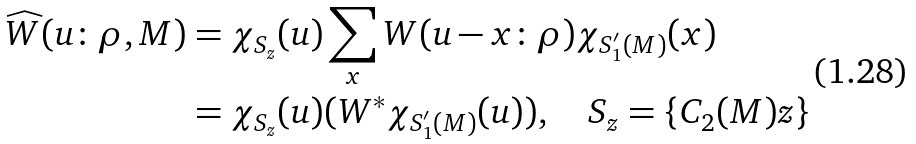<formula> <loc_0><loc_0><loc_500><loc_500>\widehat { W } ( { u } \colon \rho , M ) & = \chi _ { S _ { z } } ( { u } ) \sum _ { x } W ( { u } - { x } \colon \rho ) \chi _ { S ^ { \prime } _ { 1 } ( M ) } ( { x } ) \\ & = \chi _ { S _ { z } } ( { u } ) ( W ^ { * } \chi _ { S _ { 1 } ^ { \prime } ( M ) } ( { u } ) ) , \quad S _ { z } = \{ { C } _ { 2 } ( M ) z \} \\</formula> 